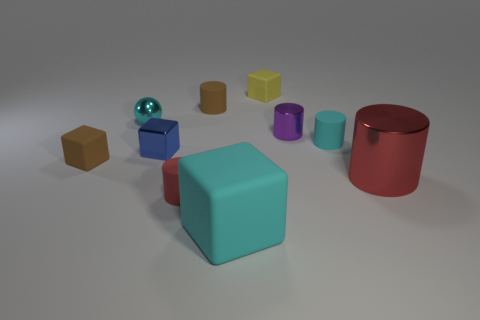Subtract 1 cylinders. How many cylinders are left? 4 Subtract all purple cylinders. How many cylinders are left? 4 Subtract all small brown cylinders. How many cylinders are left? 4 Subtract all yellow cylinders. Subtract all yellow blocks. How many cylinders are left? 5 Subtract all cubes. How many objects are left? 6 Subtract all purple metallic blocks. Subtract all cyan cylinders. How many objects are left? 9 Add 7 small purple shiny cylinders. How many small purple shiny cylinders are left? 8 Add 2 brown rubber cylinders. How many brown rubber cylinders exist? 3 Subtract 0 green blocks. How many objects are left? 10 